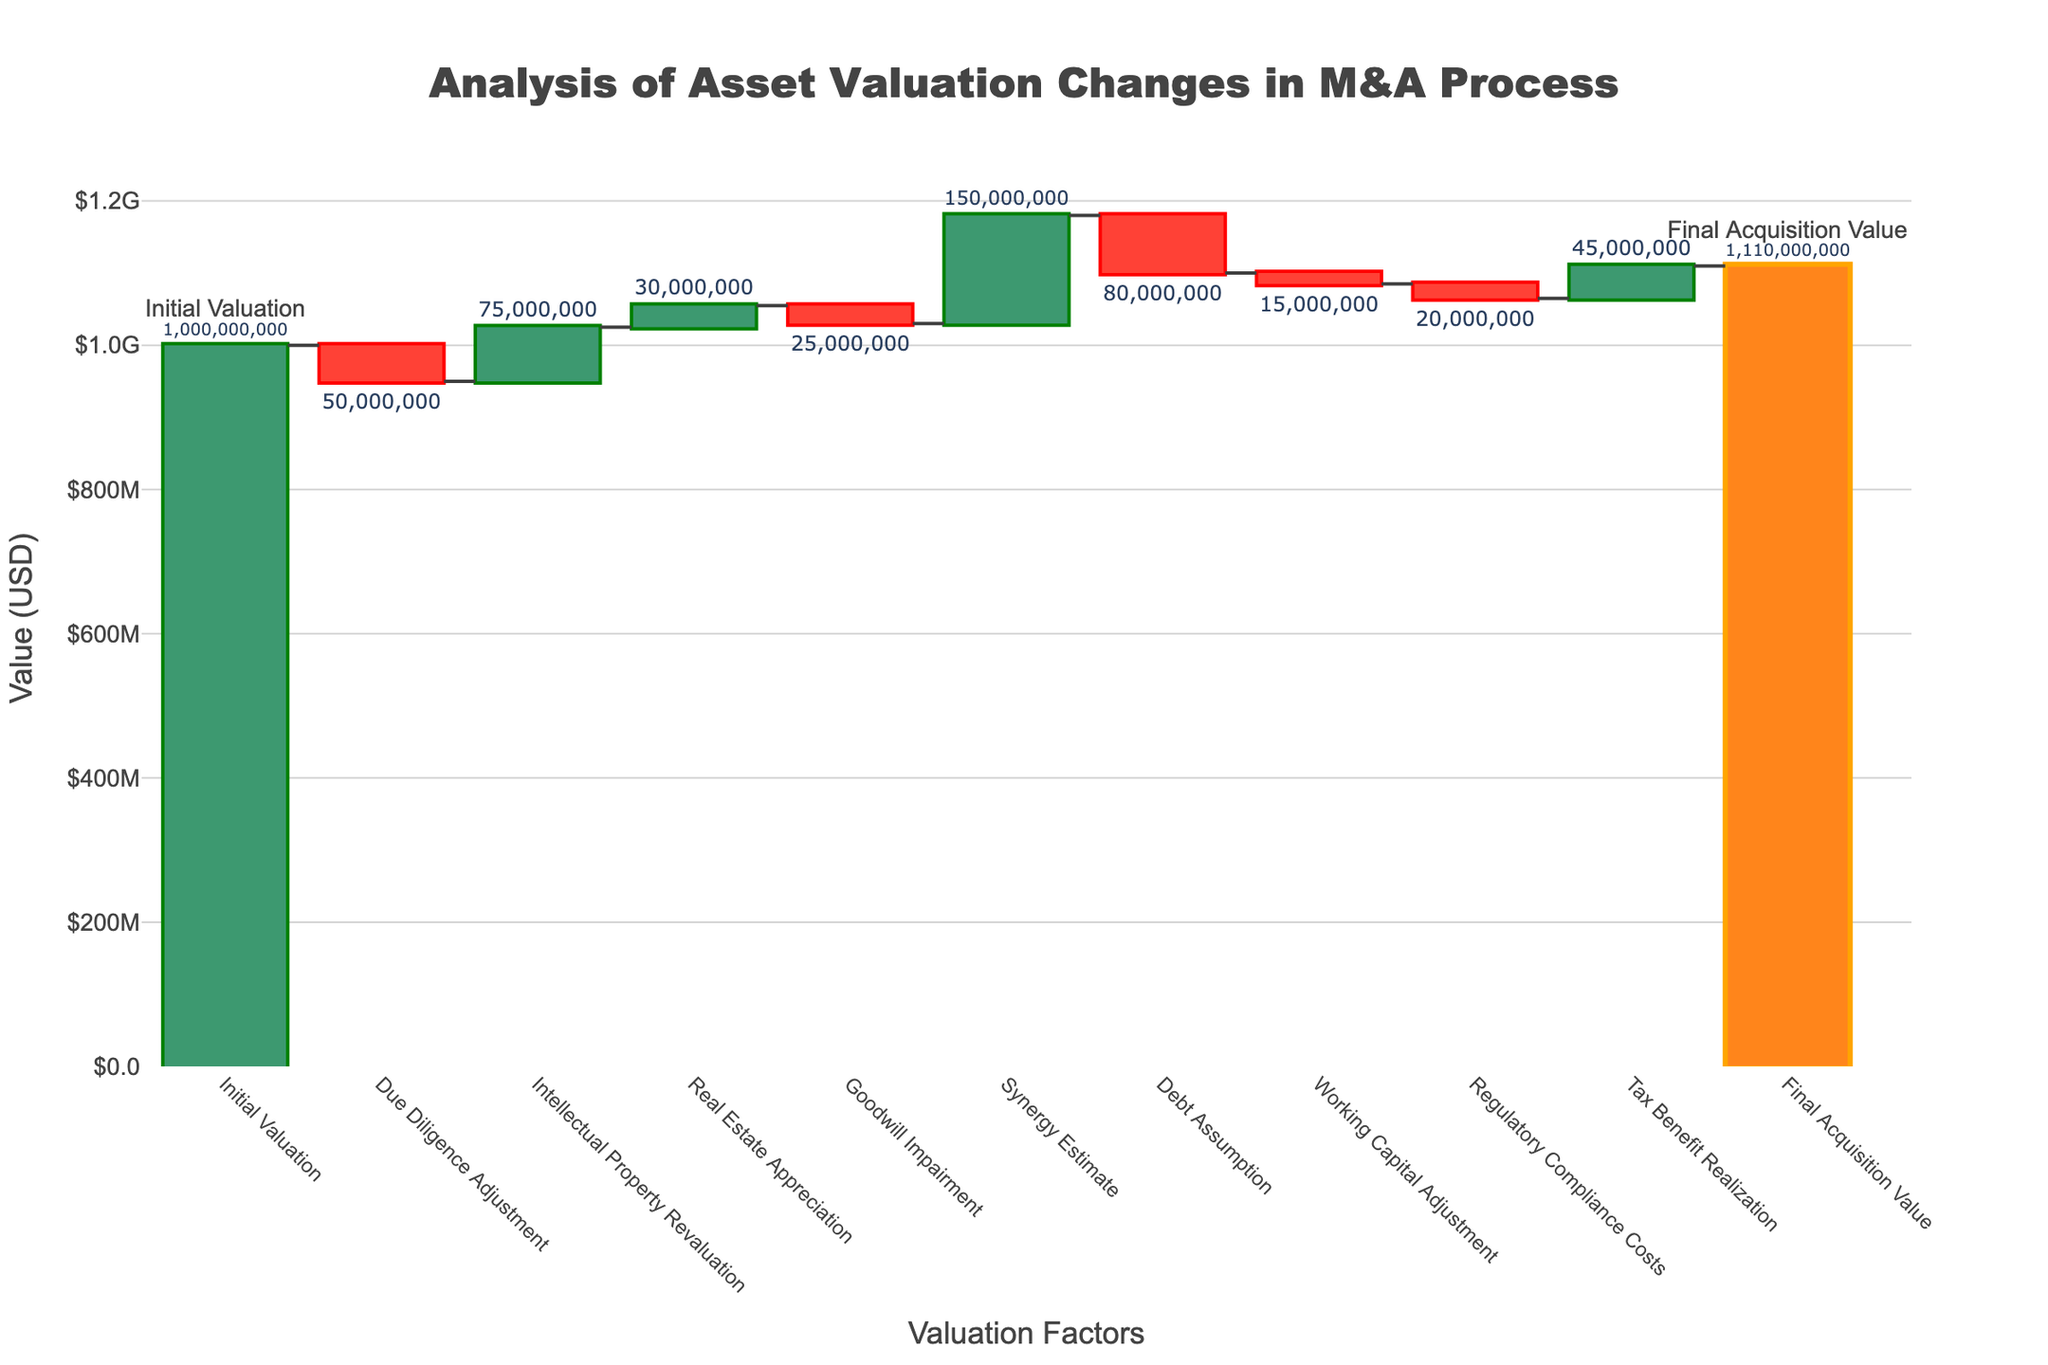How many categories are shown in the Waterfall Chart? Count the number of labeled data points on the X-axis, each representing a category.
Answer: 11 What is the initial valuation? Look at the first bar labeled "Initial Valuation" and read its value.
Answer: $1,000,000,000 Which category has the largest positive impact on the asset valuation? Examine the heights of the green bars, which indicate positive values, and identify the tallest one.
Answer: Synergy Estimate What is the value change due to regulatory compliance costs? Find the bar labeled "Regulatory Compliance Costs" and note its value.
Answer: -$20,000,000 By how much does the intellectual property revaluation raise the total valuation? Look at the height of the bar labeled "Intellectual Property Revaluation" to find its value.
Answer: $75,000,000 What is the final acquisition value? Find the last bar labeled "Final Acquisition Value" and read its value.
Answer: $1,110,000,000 What is the net change from the initial valuation to the final acquisition value? Subtract the initial valuation from the final acquisition value: $1,110,000,000 - $1,000,000,000.
Answer: $110,000,000 How do the effects of debt assumption and synergy estimate compare? Identify the values of "Debt Assumption" and "Synergy Estimate" and compare them. Debt assumption decreases by $80,000,000, and synergy estimate increases by $150,000,000.
Answer: Synergy Estimate is larger positively What is the cumulative effect of the categories that lowered the valuation? Add the values for adjustments that decreased the valuation: Due Diligence Adjustment (-$50,000,000) + Goodwill Impairment (-$25,000,000) + Debt Assumption (-$80,000,000) + Working Capital Adjustment (-$15,000,000) + Regulatory Compliance Costs (-$20,000,000).
Answer: -$190,000,000 Which categories have a positive impact on the valuation? Identify the bars with green color representing value increases: Intellectual Property Revaluation, Real Estate Appreciation, Synergy Estimate, Tax Benefit Realization.
Answer: Intellectual Property Revaluation, Real Estate Appreciation, Synergy Estimate, Tax Benefit Realization 